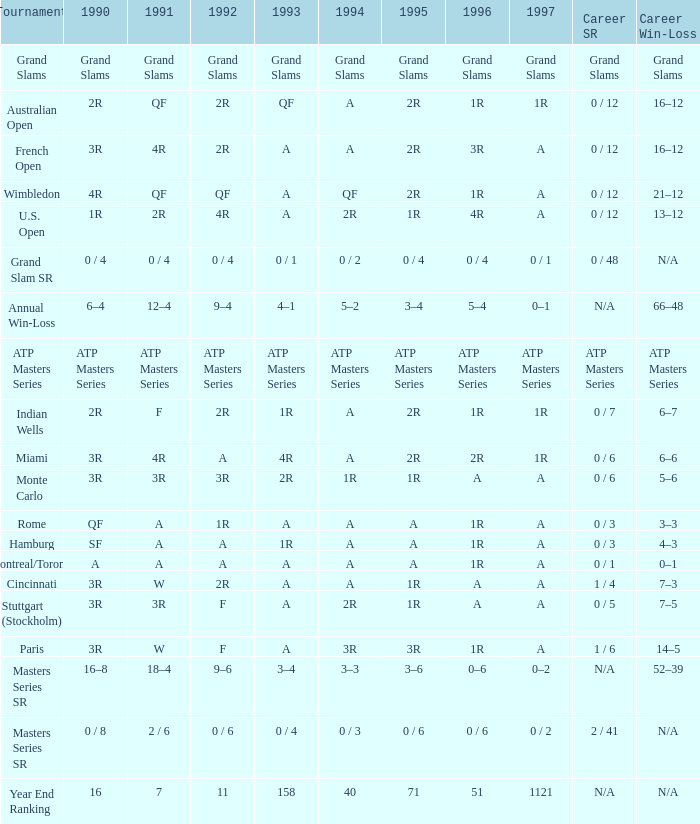What is 1996, when 1992 is "ATP Masters Series"? ATP Masters Series. 